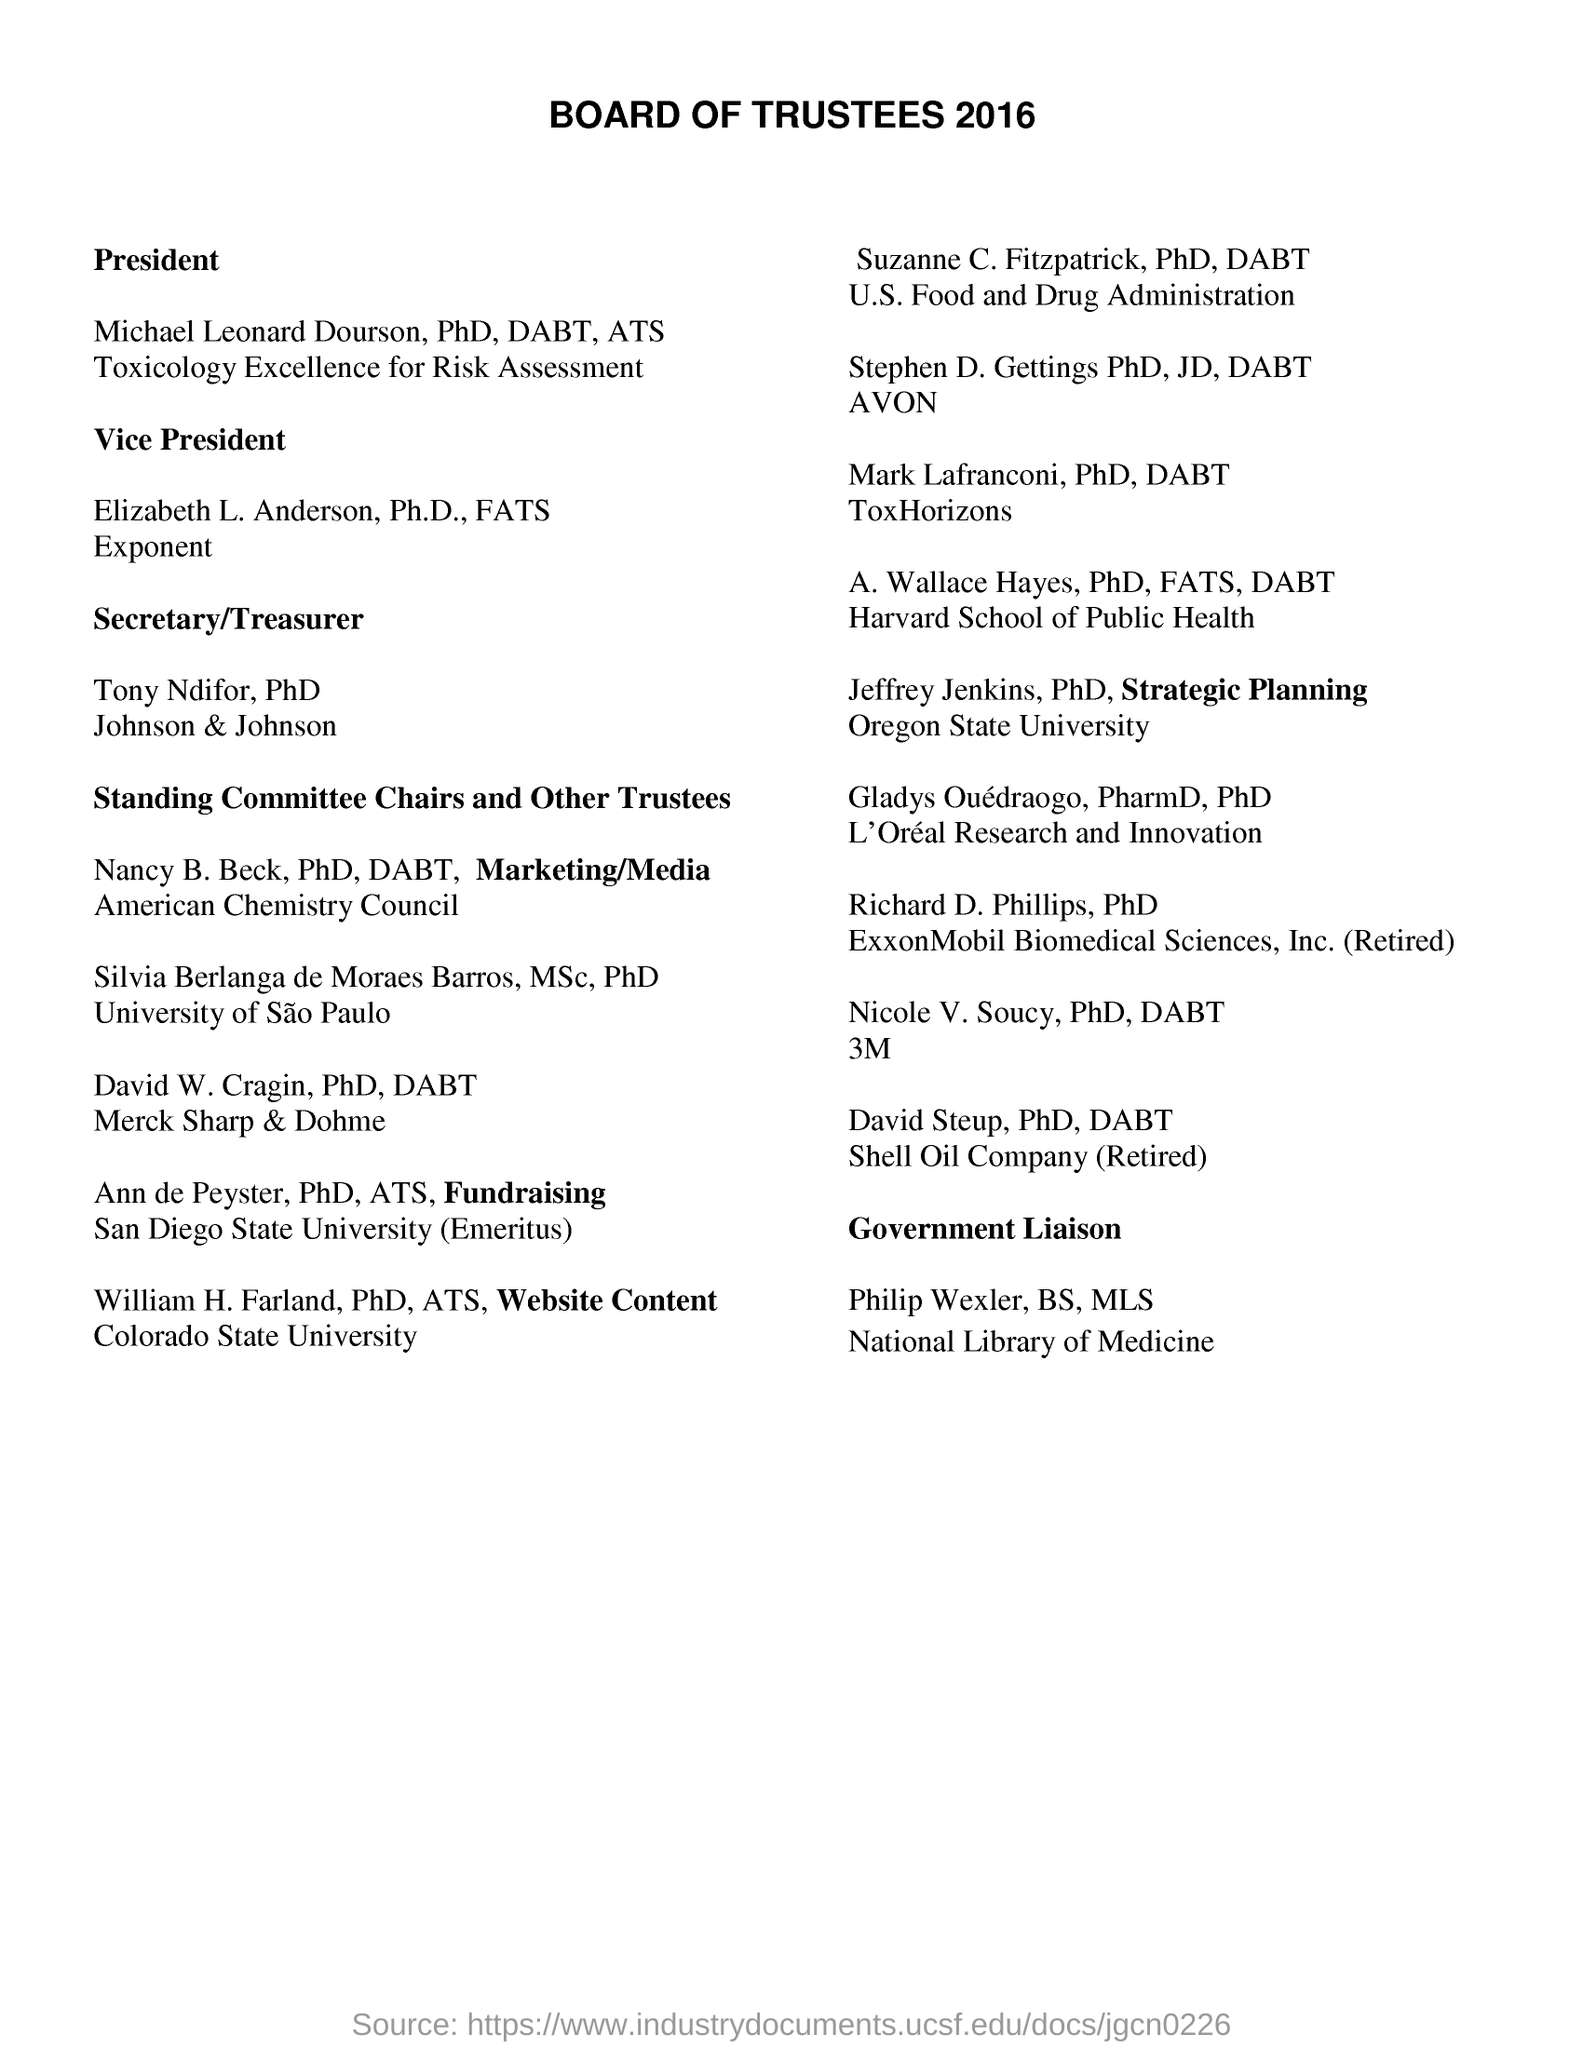Highlight a few significant elements in this photo. William H. Farland was a member of Colorado State University. The President of the BOARD OF TRUSTEES is named Michael Leonard Dourson, PhD, DABT, ATS. 